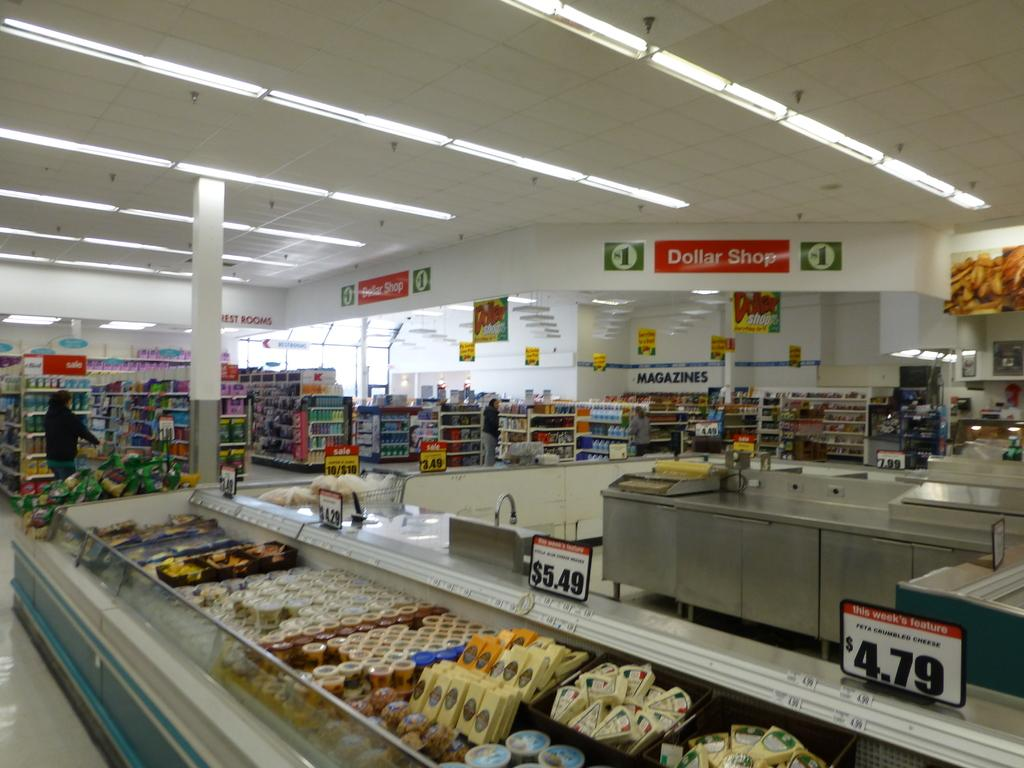Provide a one-sentence caption for the provided image. An assortment of cheeses are for sale for between four and six dollars at Dollar Shop. 